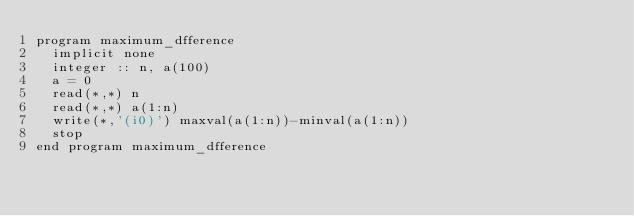<code> <loc_0><loc_0><loc_500><loc_500><_FORTRAN_>program maximum_dfference
  implicit none
  integer :: n, a(100)
  a = 0
  read(*,*) n
  read(*,*) a(1:n)
  write(*,'(i0)') maxval(a(1:n))-minval(a(1:n))
  stop
end program maximum_dfference</code> 